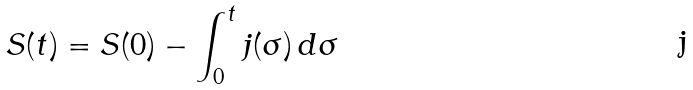<formula> <loc_0><loc_0><loc_500><loc_500>S ( t ) = S ( 0 ) - \int _ { 0 } ^ { t } j ( \sigma ) \, d \sigma</formula> 